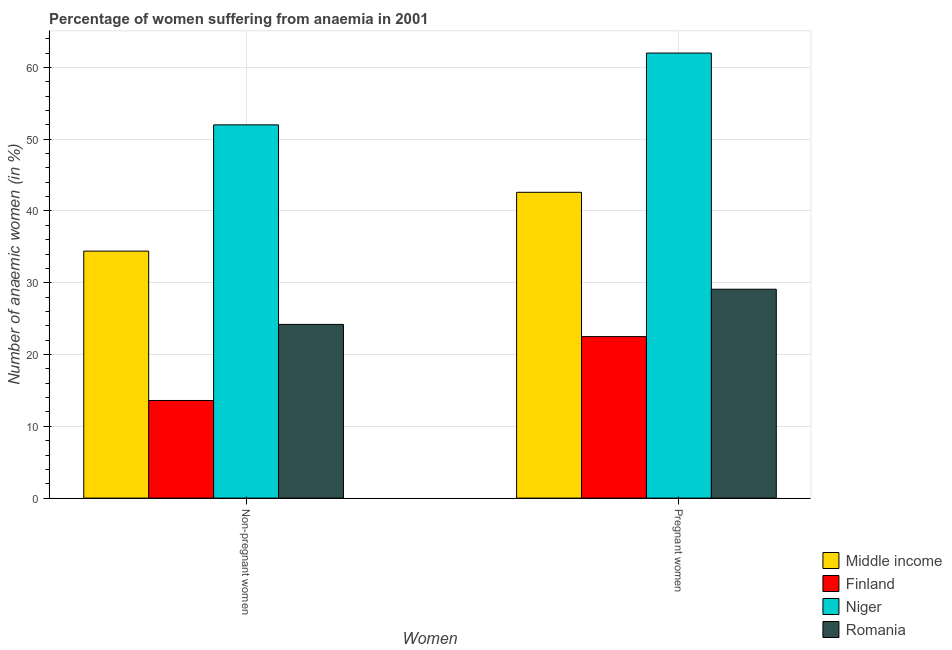How many groups of bars are there?
Ensure brevity in your answer.  2. How many bars are there on the 1st tick from the left?
Your response must be concise. 4. What is the label of the 2nd group of bars from the left?
Give a very brief answer. Pregnant women. In which country was the percentage of pregnant anaemic women maximum?
Offer a terse response. Niger. What is the total percentage of pregnant anaemic women in the graph?
Your answer should be compact. 156.2. What is the difference between the percentage of non-pregnant anaemic women in Niger and that in Finland?
Your response must be concise. 38.4. What is the difference between the percentage of non-pregnant anaemic women in Romania and the percentage of pregnant anaemic women in Middle income?
Make the answer very short. -18.4. What is the average percentage of non-pregnant anaemic women per country?
Provide a succinct answer. 31.05. What is the difference between the percentage of non-pregnant anaemic women and percentage of pregnant anaemic women in Middle income?
Provide a short and direct response. -8.19. In how many countries, is the percentage of non-pregnant anaemic women greater than 62 %?
Your answer should be very brief. 0. What is the ratio of the percentage of pregnant anaemic women in Middle income to that in Finland?
Offer a terse response. 1.89. In how many countries, is the percentage of pregnant anaemic women greater than the average percentage of pregnant anaemic women taken over all countries?
Offer a very short reply. 2. What does the 3rd bar from the left in Non-pregnant women represents?
Offer a very short reply. Niger. What does the 2nd bar from the right in Pregnant women represents?
Give a very brief answer. Niger. How many bars are there?
Provide a succinct answer. 8. How many countries are there in the graph?
Ensure brevity in your answer.  4. What is the difference between two consecutive major ticks on the Y-axis?
Your answer should be compact. 10. Are the values on the major ticks of Y-axis written in scientific E-notation?
Keep it short and to the point. No. Does the graph contain any zero values?
Provide a short and direct response. No. Where does the legend appear in the graph?
Provide a short and direct response. Bottom right. How are the legend labels stacked?
Give a very brief answer. Vertical. What is the title of the graph?
Give a very brief answer. Percentage of women suffering from anaemia in 2001. Does "Japan" appear as one of the legend labels in the graph?
Keep it short and to the point. No. What is the label or title of the X-axis?
Your answer should be very brief. Women. What is the label or title of the Y-axis?
Give a very brief answer. Number of anaemic women (in %). What is the Number of anaemic women (in %) in Middle income in Non-pregnant women?
Your response must be concise. 34.41. What is the Number of anaemic women (in %) in Finland in Non-pregnant women?
Ensure brevity in your answer.  13.6. What is the Number of anaemic women (in %) of Niger in Non-pregnant women?
Give a very brief answer. 52. What is the Number of anaemic women (in %) in Romania in Non-pregnant women?
Your response must be concise. 24.2. What is the Number of anaemic women (in %) in Middle income in Pregnant women?
Keep it short and to the point. 42.6. What is the Number of anaemic women (in %) of Finland in Pregnant women?
Offer a terse response. 22.5. What is the Number of anaemic women (in %) in Niger in Pregnant women?
Provide a short and direct response. 62. What is the Number of anaemic women (in %) of Romania in Pregnant women?
Give a very brief answer. 29.1. Across all Women, what is the maximum Number of anaemic women (in %) of Middle income?
Give a very brief answer. 42.6. Across all Women, what is the maximum Number of anaemic women (in %) of Finland?
Give a very brief answer. 22.5. Across all Women, what is the maximum Number of anaemic women (in %) of Niger?
Your answer should be very brief. 62. Across all Women, what is the maximum Number of anaemic women (in %) in Romania?
Offer a very short reply. 29.1. Across all Women, what is the minimum Number of anaemic women (in %) of Middle income?
Your response must be concise. 34.41. Across all Women, what is the minimum Number of anaemic women (in %) in Finland?
Your response must be concise. 13.6. Across all Women, what is the minimum Number of anaemic women (in %) of Romania?
Make the answer very short. 24.2. What is the total Number of anaemic women (in %) in Middle income in the graph?
Give a very brief answer. 77.01. What is the total Number of anaemic women (in %) of Finland in the graph?
Ensure brevity in your answer.  36.1. What is the total Number of anaemic women (in %) in Niger in the graph?
Your response must be concise. 114. What is the total Number of anaemic women (in %) of Romania in the graph?
Your response must be concise. 53.3. What is the difference between the Number of anaemic women (in %) of Middle income in Non-pregnant women and that in Pregnant women?
Your answer should be very brief. -8.19. What is the difference between the Number of anaemic women (in %) of Niger in Non-pregnant women and that in Pregnant women?
Provide a succinct answer. -10. What is the difference between the Number of anaemic women (in %) in Romania in Non-pregnant women and that in Pregnant women?
Ensure brevity in your answer.  -4.9. What is the difference between the Number of anaemic women (in %) of Middle income in Non-pregnant women and the Number of anaemic women (in %) of Finland in Pregnant women?
Your response must be concise. 11.91. What is the difference between the Number of anaemic women (in %) of Middle income in Non-pregnant women and the Number of anaemic women (in %) of Niger in Pregnant women?
Keep it short and to the point. -27.59. What is the difference between the Number of anaemic women (in %) of Middle income in Non-pregnant women and the Number of anaemic women (in %) of Romania in Pregnant women?
Offer a terse response. 5.31. What is the difference between the Number of anaemic women (in %) of Finland in Non-pregnant women and the Number of anaemic women (in %) of Niger in Pregnant women?
Your answer should be very brief. -48.4. What is the difference between the Number of anaemic women (in %) in Finland in Non-pregnant women and the Number of anaemic women (in %) in Romania in Pregnant women?
Keep it short and to the point. -15.5. What is the difference between the Number of anaemic women (in %) of Niger in Non-pregnant women and the Number of anaemic women (in %) of Romania in Pregnant women?
Make the answer very short. 22.9. What is the average Number of anaemic women (in %) in Middle income per Women?
Your answer should be very brief. 38.51. What is the average Number of anaemic women (in %) in Finland per Women?
Provide a short and direct response. 18.05. What is the average Number of anaemic women (in %) in Romania per Women?
Your response must be concise. 26.65. What is the difference between the Number of anaemic women (in %) of Middle income and Number of anaemic women (in %) of Finland in Non-pregnant women?
Offer a terse response. 20.81. What is the difference between the Number of anaemic women (in %) of Middle income and Number of anaemic women (in %) of Niger in Non-pregnant women?
Your response must be concise. -17.59. What is the difference between the Number of anaemic women (in %) of Middle income and Number of anaemic women (in %) of Romania in Non-pregnant women?
Offer a very short reply. 10.21. What is the difference between the Number of anaemic women (in %) of Finland and Number of anaemic women (in %) of Niger in Non-pregnant women?
Your answer should be compact. -38.4. What is the difference between the Number of anaemic women (in %) of Finland and Number of anaemic women (in %) of Romania in Non-pregnant women?
Give a very brief answer. -10.6. What is the difference between the Number of anaemic women (in %) of Niger and Number of anaemic women (in %) of Romania in Non-pregnant women?
Keep it short and to the point. 27.8. What is the difference between the Number of anaemic women (in %) in Middle income and Number of anaemic women (in %) in Finland in Pregnant women?
Your answer should be compact. 20.1. What is the difference between the Number of anaemic women (in %) of Middle income and Number of anaemic women (in %) of Niger in Pregnant women?
Your answer should be very brief. -19.4. What is the difference between the Number of anaemic women (in %) in Middle income and Number of anaemic women (in %) in Romania in Pregnant women?
Your response must be concise. 13.5. What is the difference between the Number of anaemic women (in %) of Finland and Number of anaemic women (in %) of Niger in Pregnant women?
Provide a succinct answer. -39.5. What is the difference between the Number of anaemic women (in %) of Niger and Number of anaemic women (in %) of Romania in Pregnant women?
Your answer should be compact. 32.9. What is the ratio of the Number of anaemic women (in %) in Middle income in Non-pregnant women to that in Pregnant women?
Provide a succinct answer. 0.81. What is the ratio of the Number of anaemic women (in %) of Finland in Non-pregnant women to that in Pregnant women?
Ensure brevity in your answer.  0.6. What is the ratio of the Number of anaemic women (in %) in Niger in Non-pregnant women to that in Pregnant women?
Your response must be concise. 0.84. What is the ratio of the Number of anaemic women (in %) of Romania in Non-pregnant women to that in Pregnant women?
Make the answer very short. 0.83. What is the difference between the highest and the second highest Number of anaemic women (in %) of Middle income?
Ensure brevity in your answer.  8.19. What is the difference between the highest and the second highest Number of anaemic women (in %) of Finland?
Offer a very short reply. 8.9. What is the difference between the highest and the second highest Number of anaemic women (in %) in Romania?
Offer a very short reply. 4.9. What is the difference between the highest and the lowest Number of anaemic women (in %) of Middle income?
Offer a very short reply. 8.19. What is the difference between the highest and the lowest Number of anaemic women (in %) of Finland?
Your response must be concise. 8.9. 